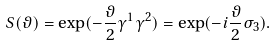Convert formula to latex. <formula><loc_0><loc_0><loc_500><loc_500>S ( \vartheta ) = \exp ( - \frac { \vartheta } { 2 } \gamma ^ { 1 } \gamma ^ { 2 } ) = \exp ( - i \frac { \vartheta } { 2 } \sigma _ { 3 } ) .</formula> 